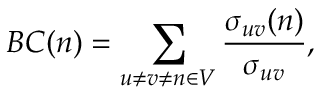<formula> <loc_0><loc_0><loc_500><loc_500>B C ( n ) = \sum _ { u \neq v \neq n \in V } \frac { \sigma _ { u v } ( n ) } { \sigma _ { u v } } ,</formula> 